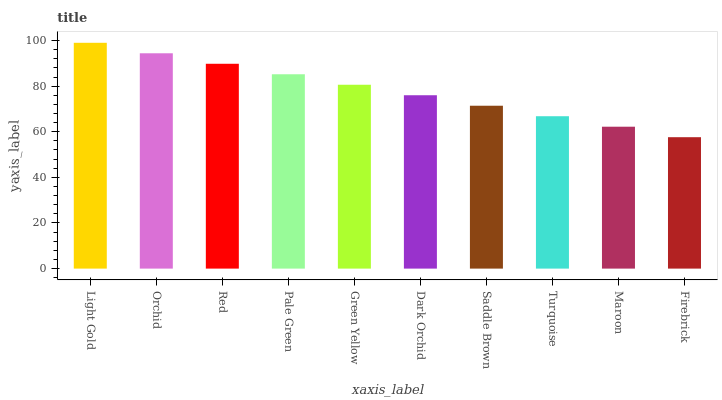Is Firebrick the minimum?
Answer yes or no. Yes. Is Light Gold the maximum?
Answer yes or no. Yes. Is Orchid the minimum?
Answer yes or no. No. Is Orchid the maximum?
Answer yes or no. No. Is Light Gold greater than Orchid?
Answer yes or no. Yes. Is Orchid less than Light Gold?
Answer yes or no. Yes. Is Orchid greater than Light Gold?
Answer yes or no. No. Is Light Gold less than Orchid?
Answer yes or no. No. Is Green Yellow the high median?
Answer yes or no. Yes. Is Dark Orchid the low median?
Answer yes or no. Yes. Is Light Gold the high median?
Answer yes or no. No. Is Firebrick the low median?
Answer yes or no. No. 